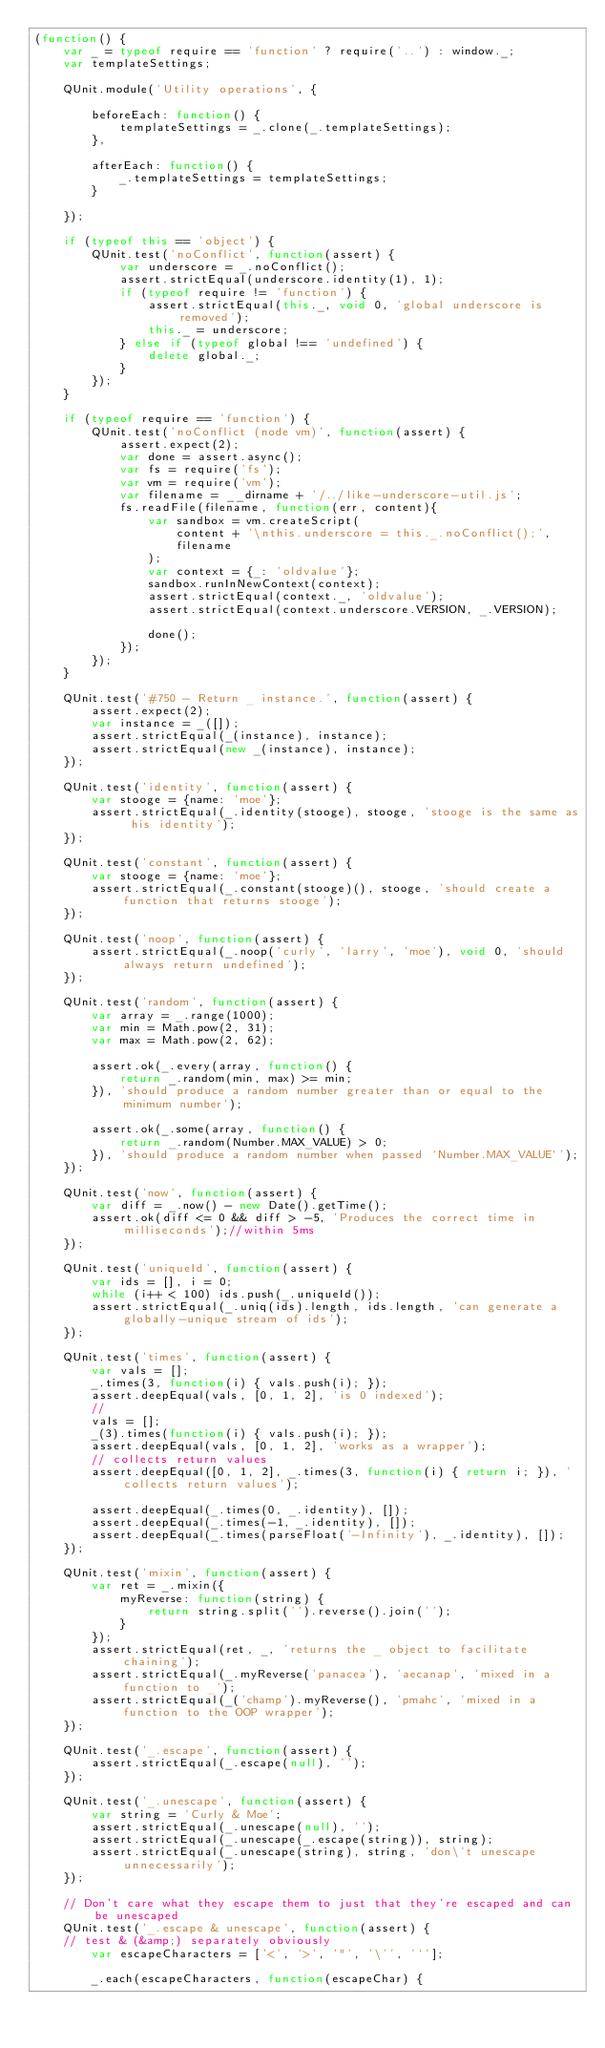Convert code to text. <code><loc_0><loc_0><loc_500><loc_500><_JavaScript_>(function() {
    var _ = typeof require == 'function' ? require('..') : window._;
    var templateSettings;

    QUnit.module('Utility operations', {

        beforeEach: function() {
            templateSettings = _.clone(_.templateSettings);
        },

        afterEach: function() {
            _.templateSettings = templateSettings;
        }

    });

    if (typeof this == 'object') {
        QUnit.test('noConflict', function(assert) {
            var underscore = _.noConflict();
            assert.strictEqual(underscore.identity(1), 1);
            if (typeof require != 'function') {
                assert.strictEqual(this._, void 0, 'global underscore is removed');
                this._ = underscore;
            } else if (typeof global !== 'undefined') {
                delete global._;
            }
        });
    }

    if (typeof require == 'function') {
        QUnit.test('noConflict (node vm)', function(assert) {
            assert.expect(2);
            var done = assert.async();
            var fs = require('fs');
            var vm = require('vm');
            var filename = __dirname + '/../like-underscore-util.js';
            fs.readFile(filename, function(err, content){
                var sandbox = vm.createScript(
                    content + '\nthis.underscore = this._.noConflict();',
                    filename
                );
                var context = {_: 'oldvalue'};
                sandbox.runInNewContext(context);
                assert.strictEqual(context._, 'oldvalue');
                assert.strictEqual(context.underscore.VERSION, _.VERSION);

                done();
            });
        });
    }

    QUnit.test('#750 - Return _ instance.', function(assert) {
        assert.expect(2);
        var instance = _([]);
        assert.strictEqual(_(instance), instance);
        assert.strictEqual(new _(instance), instance);
    });

    QUnit.test('identity', function(assert) {
        var stooge = {name: 'moe'};
        assert.strictEqual(_.identity(stooge), stooge, 'stooge is the same as his identity');
    });

    QUnit.test('constant', function(assert) {
        var stooge = {name: 'moe'};
        assert.strictEqual(_.constant(stooge)(), stooge, 'should create a function that returns stooge');
    });

    QUnit.test('noop', function(assert) {
        assert.strictEqual(_.noop('curly', 'larry', 'moe'), void 0, 'should always return undefined');
    });

    QUnit.test('random', function(assert) {
        var array = _.range(1000);
        var min = Math.pow(2, 31);
        var max = Math.pow(2, 62);

        assert.ok(_.every(array, function() {
            return _.random(min, max) >= min;
        }), 'should produce a random number greater than or equal to the minimum number');

        assert.ok(_.some(array, function() {
            return _.random(Number.MAX_VALUE) > 0;
        }), 'should produce a random number when passed `Number.MAX_VALUE`');
    });

    QUnit.test('now', function(assert) {
        var diff = _.now() - new Date().getTime();
        assert.ok(diff <= 0 && diff > -5, 'Produces the correct time in milliseconds');//within 5ms
    });

    QUnit.test('uniqueId', function(assert) {
        var ids = [], i = 0;
        while (i++ < 100) ids.push(_.uniqueId());
        assert.strictEqual(_.uniq(ids).length, ids.length, 'can generate a globally-unique stream of ids');
    });

    QUnit.test('times', function(assert) {
        var vals = [];
        _.times(3, function(i) { vals.push(i); });
        assert.deepEqual(vals, [0, 1, 2], 'is 0 indexed');
        //
        vals = [];
        _(3).times(function(i) { vals.push(i); });
        assert.deepEqual(vals, [0, 1, 2], 'works as a wrapper');
        // collects return values
        assert.deepEqual([0, 1, 2], _.times(3, function(i) { return i; }), 'collects return values');

        assert.deepEqual(_.times(0, _.identity), []);
        assert.deepEqual(_.times(-1, _.identity), []);
        assert.deepEqual(_.times(parseFloat('-Infinity'), _.identity), []);
    });

    QUnit.test('mixin', function(assert) {
        var ret = _.mixin({
            myReverse: function(string) {
                return string.split('').reverse().join('');
            }
        });
        assert.strictEqual(ret, _, 'returns the _ object to facilitate chaining');
        assert.strictEqual(_.myReverse('panacea'), 'aecanap', 'mixed in a function to _');
        assert.strictEqual(_('champ').myReverse(), 'pmahc', 'mixed in a function to the OOP wrapper');
    });

    QUnit.test('_.escape', function(assert) {
        assert.strictEqual(_.escape(null), '');
    });

    QUnit.test('_.unescape', function(assert) {
        var string = 'Curly & Moe';
        assert.strictEqual(_.unescape(null), '');
        assert.strictEqual(_.unescape(_.escape(string)), string);
        assert.strictEqual(_.unescape(string), string, 'don\'t unescape unnecessarily');
    });

    // Don't care what they escape them to just that they're escaped and can be unescaped
    QUnit.test('_.escape & unescape', function(assert) {
    // test & (&amp;) separately obviously
        var escapeCharacters = ['<', '>', '"', '\'', '`'];

        _.each(escapeCharacters, function(escapeChar) {</code> 